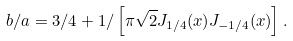<formula> <loc_0><loc_0><loc_500><loc_500>b / a = 3 / 4 + 1 / \left [ \pi \sqrt { 2 } J _ { 1 / 4 } ( x ) J _ { - 1 / 4 } ( x ) \right ] .</formula> 